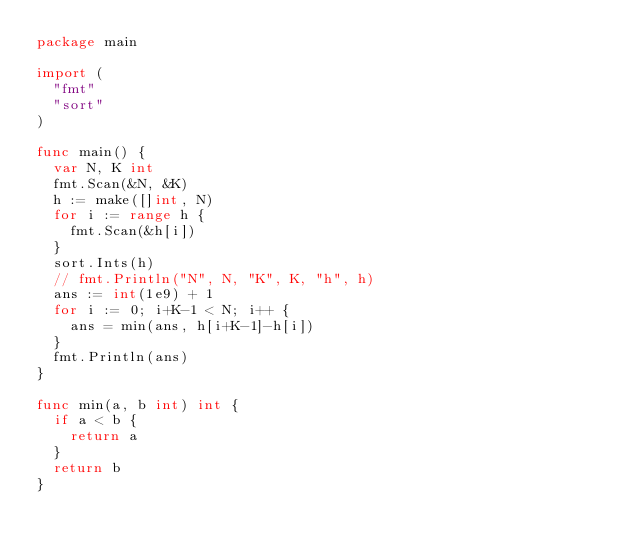Convert code to text. <code><loc_0><loc_0><loc_500><loc_500><_Go_>package main

import (
	"fmt"
	"sort"
)

func main() {
	var N, K int
	fmt.Scan(&N, &K)
	h := make([]int, N)
	for i := range h {
		fmt.Scan(&h[i])
	}
	sort.Ints(h)
	// fmt.Println("N", N, "K", K, "h", h)
	ans := int(1e9) + 1
	for i := 0; i+K-1 < N; i++ {
		ans = min(ans, h[i+K-1]-h[i])
	}
	fmt.Println(ans)
}

func min(a, b int) int {
	if a < b {
		return a
	}
	return b
}
</code> 